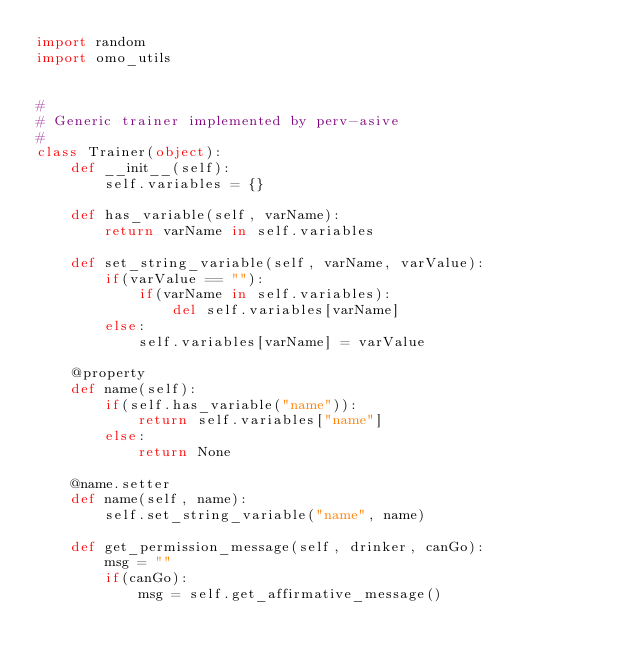<code> <loc_0><loc_0><loc_500><loc_500><_Python_>import random
import omo_utils


#
# Generic trainer implemented by perv-asive
#
class Trainer(object):
    def __init__(self):
        self.variables = {}

    def has_variable(self, varName):
        return varName in self.variables

    def set_string_variable(self, varName, varValue):
        if(varValue == ""):
            if(varName in self.variables):
                del self.variables[varName]
        else:
            self.variables[varName] = varValue

    @property
    def name(self):
        if(self.has_variable("name")):
            return self.variables["name"]
        else:
            return None

    @name.setter
    def name(self, name):
        self.set_string_variable("name", name)

    def get_permission_message(self, drinker, canGo):
        msg = ""
        if(canGo):
            msg = self.get_affirmative_message()</code> 